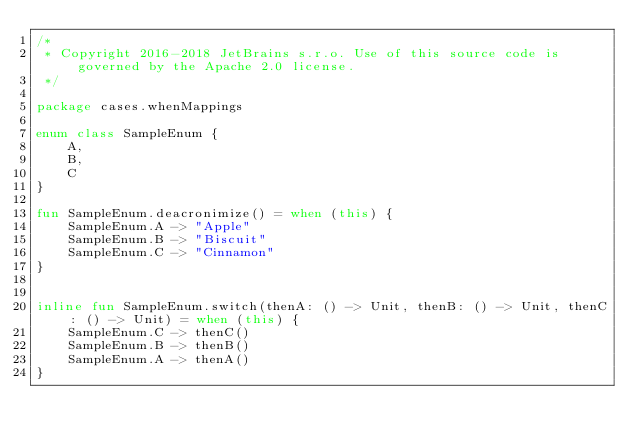<code> <loc_0><loc_0><loc_500><loc_500><_Kotlin_>/*
 * Copyright 2016-2018 JetBrains s.r.o. Use of this source code is governed by the Apache 2.0 license.
 */

package cases.whenMappings

enum class SampleEnum {
    A,
    B,
    C
}

fun SampleEnum.deacronimize() = when (this) {
    SampleEnum.A -> "Apple"
    SampleEnum.B -> "Biscuit"
    SampleEnum.C -> "Cinnamon"
}


inline fun SampleEnum.switch(thenA: () -> Unit, thenB: () -> Unit, thenC: () -> Unit) = when (this) {
    SampleEnum.C -> thenC()
    SampleEnum.B -> thenB()
    SampleEnum.A -> thenA()
}
</code> 